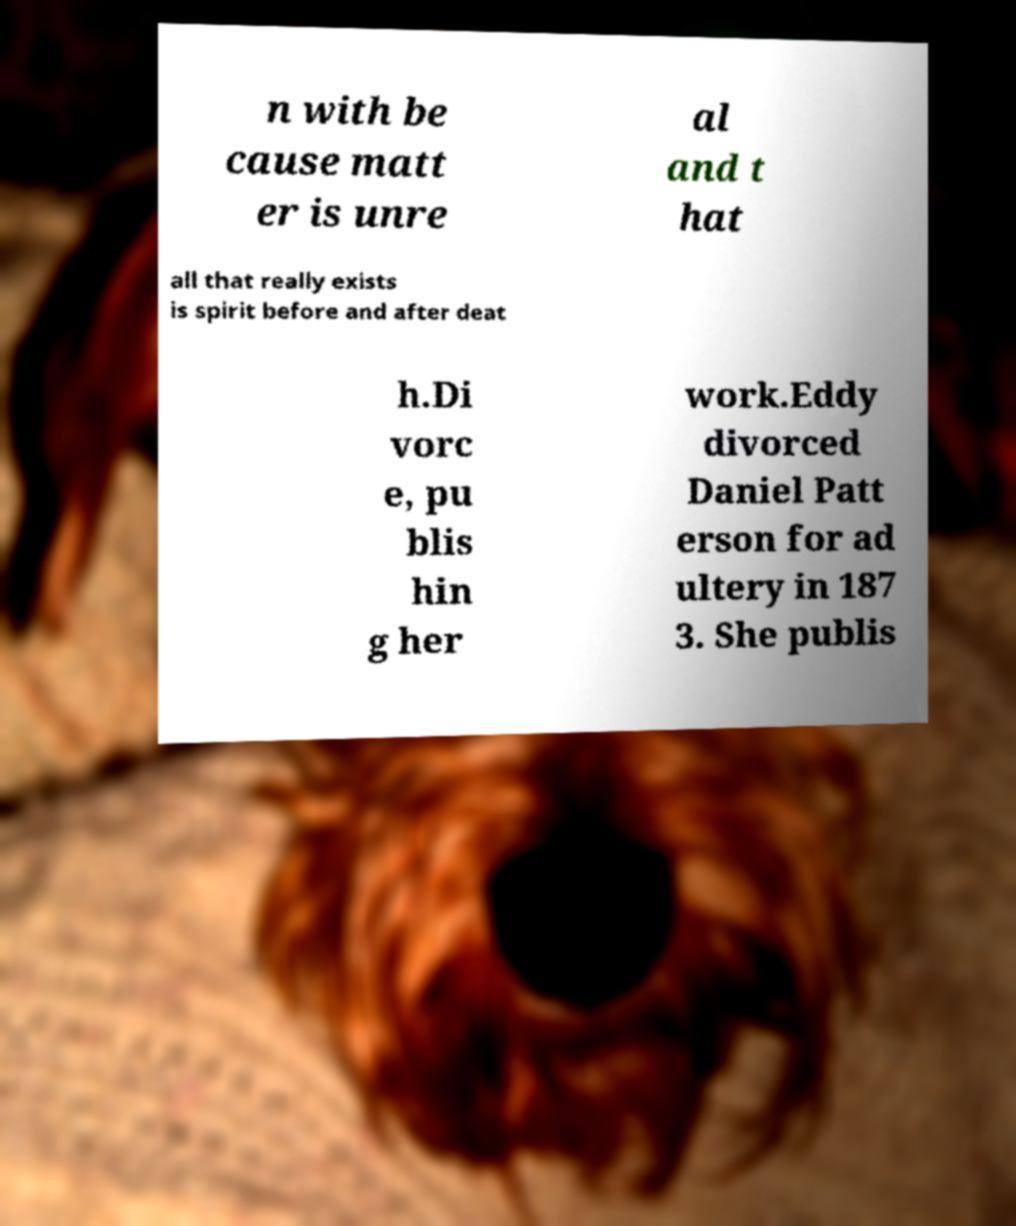Could you assist in decoding the text presented in this image and type it out clearly? n with be cause matt er is unre al and t hat all that really exists is spirit before and after deat h.Di vorc e, pu blis hin g her work.Eddy divorced Daniel Patt erson for ad ultery in 187 3. She publis 